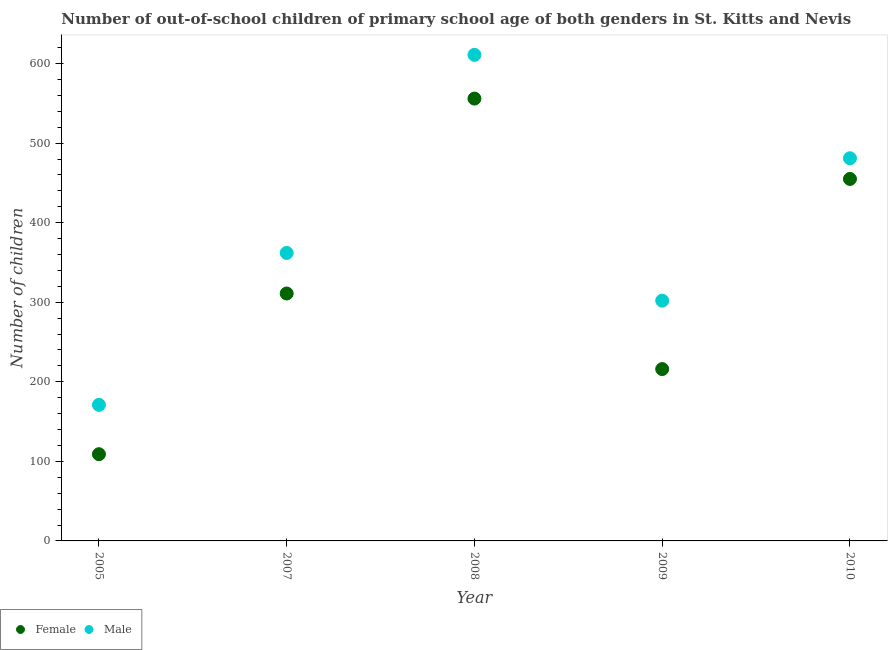How many different coloured dotlines are there?
Offer a very short reply. 2. What is the number of male out-of-school students in 2005?
Your response must be concise. 171. Across all years, what is the maximum number of male out-of-school students?
Give a very brief answer. 611. Across all years, what is the minimum number of male out-of-school students?
Keep it short and to the point. 171. In which year was the number of female out-of-school students maximum?
Offer a very short reply. 2008. What is the total number of female out-of-school students in the graph?
Offer a very short reply. 1647. What is the difference between the number of male out-of-school students in 2005 and that in 2009?
Make the answer very short. -131. What is the difference between the number of male out-of-school students in 2007 and the number of female out-of-school students in 2009?
Keep it short and to the point. 146. What is the average number of female out-of-school students per year?
Ensure brevity in your answer.  329.4. In the year 2009, what is the difference between the number of male out-of-school students and number of female out-of-school students?
Provide a short and direct response. 86. In how many years, is the number of male out-of-school students greater than 120?
Provide a succinct answer. 5. What is the ratio of the number of female out-of-school students in 2009 to that in 2010?
Keep it short and to the point. 0.47. Is the number of male out-of-school students in 2009 less than that in 2010?
Your response must be concise. Yes. Is the difference between the number of female out-of-school students in 2005 and 2010 greater than the difference between the number of male out-of-school students in 2005 and 2010?
Offer a very short reply. No. What is the difference between the highest and the second highest number of female out-of-school students?
Your answer should be very brief. 101. What is the difference between the highest and the lowest number of male out-of-school students?
Offer a very short reply. 440. In how many years, is the number of male out-of-school students greater than the average number of male out-of-school students taken over all years?
Ensure brevity in your answer.  2. Does the number of male out-of-school students monotonically increase over the years?
Your response must be concise. No. Is the number of female out-of-school students strictly greater than the number of male out-of-school students over the years?
Your answer should be compact. No. How many dotlines are there?
Keep it short and to the point. 2. How many years are there in the graph?
Give a very brief answer. 5. What is the difference between two consecutive major ticks on the Y-axis?
Your response must be concise. 100. Are the values on the major ticks of Y-axis written in scientific E-notation?
Provide a short and direct response. No. Does the graph contain any zero values?
Ensure brevity in your answer.  No. Does the graph contain grids?
Your answer should be very brief. No. How many legend labels are there?
Keep it short and to the point. 2. How are the legend labels stacked?
Offer a very short reply. Horizontal. What is the title of the graph?
Offer a terse response. Number of out-of-school children of primary school age of both genders in St. Kitts and Nevis. What is the label or title of the Y-axis?
Offer a very short reply. Number of children. What is the Number of children in Female in 2005?
Keep it short and to the point. 109. What is the Number of children in Male in 2005?
Your answer should be compact. 171. What is the Number of children of Female in 2007?
Keep it short and to the point. 311. What is the Number of children of Male in 2007?
Ensure brevity in your answer.  362. What is the Number of children of Female in 2008?
Your answer should be very brief. 556. What is the Number of children in Male in 2008?
Your response must be concise. 611. What is the Number of children of Female in 2009?
Offer a very short reply. 216. What is the Number of children in Male in 2009?
Ensure brevity in your answer.  302. What is the Number of children in Female in 2010?
Your response must be concise. 455. What is the Number of children in Male in 2010?
Your response must be concise. 481. Across all years, what is the maximum Number of children in Female?
Provide a short and direct response. 556. Across all years, what is the maximum Number of children in Male?
Offer a terse response. 611. Across all years, what is the minimum Number of children of Female?
Ensure brevity in your answer.  109. Across all years, what is the minimum Number of children in Male?
Give a very brief answer. 171. What is the total Number of children of Female in the graph?
Make the answer very short. 1647. What is the total Number of children in Male in the graph?
Your response must be concise. 1927. What is the difference between the Number of children of Female in 2005 and that in 2007?
Your response must be concise. -202. What is the difference between the Number of children of Male in 2005 and that in 2007?
Ensure brevity in your answer.  -191. What is the difference between the Number of children of Female in 2005 and that in 2008?
Make the answer very short. -447. What is the difference between the Number of children of Male in 2005 and that in 2008?
Provide a succinct answer. -440. What is the difference between the Number of children in Female in 2005 and that in 2009?
Make the answer very short. -107. What is the difference between the Number of children in Male in 2005 and that in 2009?
Offer a terse response. -131. What is the difference between the Number of children of Female in 2005 and that in 2010?
Your answer should be compact. -346. What is the difference between the Number of children of Male in 2005 and that in 2010?
Offer a terse response. -310. What is the difference between the Number of children in Female in 2007 and that in 2008?
Provide a short and direct response. -245. What is the difference between the Number of children of Male in 2007 and that in 2008?
Make the answer very short. -249. What is the difference between the Number of children in Female in 2007 and that in 2010?
Your response must be concise. -144. What is the difference between the Number of children in Male in 2007 and that in 2010?
Keep it short and to the point. -119. What is the difference between the Number of children in Female in 2008 and that in 2009?
Your answer should be very brief. 340. What is the difference between the Number of children of Male in 2008 and that in 2009?
Give a very brief answer. 309. What is the difference between the Number of children in Female in 2008 and that in 2010?
Your answer should be compact. 101. What is the difference between the Number of children in Male in 2008 and that in 2010?
Provide a succinct answer. 130. What is the difference between the Number of children of Female in 2009 and that in 2010?
Offer a terse response. -239. What is the difference between the Number of children of Male in 2009 and that in 2010?
Provide a succinct answer. -179. What is the difference between the Number of children in Female in 2005 and the Number of children in Male in 2007?
Your response must be concise. -253. What is the difference between the Number of children of Female in 2005 and the Number of children of Male in 2008?
Offer a very short reply. -502. What is the difference between the Number of children of Female in 2005 and the Number of children of Male in 2009?
Give a very brief answer. -193. What is the difference between the Number of children of Female in 2005 and the Number of children of Male in 2010?
Provide a short and direct response. -372. What is the difference between the Number of children in Female in 2007 and the Number of children in Male in 2008?
Keep it short and to the point. -300. What is the difference between the Number of children of Female in 2007 and the Number of children of Male in 2009?
Make the answer very short. 9. What is the difference between the Number of children of Female in 2007 and the Number of children of Male in 2010?
Your answer should be very brief. -170. What is the difference between the Number of children in Female in 2008 and the Number of children in Male in 2009?
Offer a very short reply. 254. What is the difference between the Number of children of Female in 2008 and the Number of children of Male in 2010?
Your answer should be compact. 75. What is the difference between the Number of children in Female in 2009 and the Number of children in Male in 2010?
Offer a terse response. -265. What is the average Number of children of Female per year?
Offer a terse response. 329.4. What is the average Number of children in Male per year?
Provide a short and direct response. 385.4. In the year 2005, what is the difference between the Number of children in Female and Number of children in Male?
Your response must be concise. -62. In the year 2007, what is the difference between the Number of children in Female and Number of children in Male?
Keep it short and to the point. -51. In the year 2008, what is the difference between the Number of children of Female and Number of children of Male?
Offer a terse response. -55. In the year 2009, what is the difference between the Number of children in Female and Number of children in Male?
Offer a very short reply. -86. In the year 2010, what is the difference between the Number of children of Female and Number of children of Male?
Ensure brevity in your answer.  -26. What is the ratio of the Number of children in Female in 2005 to that in 2007?
Your answer should be compact. 0.35. What is the ratio of the Number of children in Male in 2005 to that in 2007?
Your answer should be very brief. 0.47. What is the ratio of the Number of children in Female in 2005 to that in 2008?
Make the answer very short. 0.2. What is the ratio of the Number of children in Male in 2005 to that in 2008?
Give a very brief answer. 0.28. What is the ratio of the Number of children in Female in 2005 to that in 2009?
Keep it short and to the point. 0.5. What is the ratio of the Number of children in Male in 2005 to that in 2009?
Ensure brevity in your answer.  0.57. What is the ratio of the Number of children in Female in 2005 to that in 2010?
Provide a succinct answer. 0.24. What is the ratio of the Number of children of Male in 2005 to that in 2010?
Ensure brevity in your answer.  0.36. What is the ratio of the Number of children in Female in 2007 to that in 2008?
Give a very brief answer. 0.56. What is the ratio of the Number of children of Male in 2007 to that in 2008?
Ensure brevity in your answer.  0.59. What is the ratio of the Number of children of Female in 2007 to that in 2009?
Offer a very short reply. 1.44. What is the ratio of the Number of children in Male in 2007 to that in 2009?
Your response must be concise. 1.2. What is the ratio of the Number of children of Female in 2007 to that in 2010?
Your response must be concise. 0.68. What is the ratio of the Number of children in Male in 2007 to that in 2010?
Provide a short and direct response. 0.75. What is the ratio of the Number of children of Female in 2008 to that in 2009?
Provide a succinct answer. 2.57. What is the ratio of the Number of children in Male in 2008 to that in 2009?
Your response must be concise. 2.02. What is the ratio of the Number of children in Female in 2008 to that in 2010?
Offer a very short reply. 1.22. What is the ratio of the Number of children of Male in 2008 to that in 2010?
Your response must be concise. 1.27. What is the ratio of the Number of children in Female in 2009 to that in 2010?
Provide a succinct answer. 0.47. What is the ratio of the Number of children of Male in 2009 to that in 2010?
Offer a very short reply. 0.63. What is the difference between the highest and the second highest Number of children in Female?
Provide a short and direct response. 101. What is the difference between the highest and the second highest Number of children of Male?
Ensure brevity in your answer.  130. What is the difference between the highest and the lowest Number of children of Female?
Offer a terse response. 447. What is the difference between the highest and the lowest Number of children in Male?
Offer a very short reply. 440. 